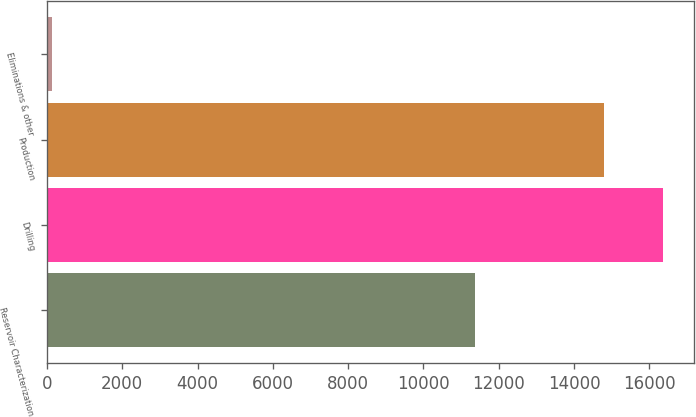Convert chart to OTSL. <chart><loc_0><loc_0><loc_500><loc_500><bar_chart><fcel>Reservoir Characterization<fcel>Drilling<fcel>Production<fcel>Eliminations & other<nl><fcel>11360<fcel>16358.9<fcel>14802<fcel>122<nl></chart> 